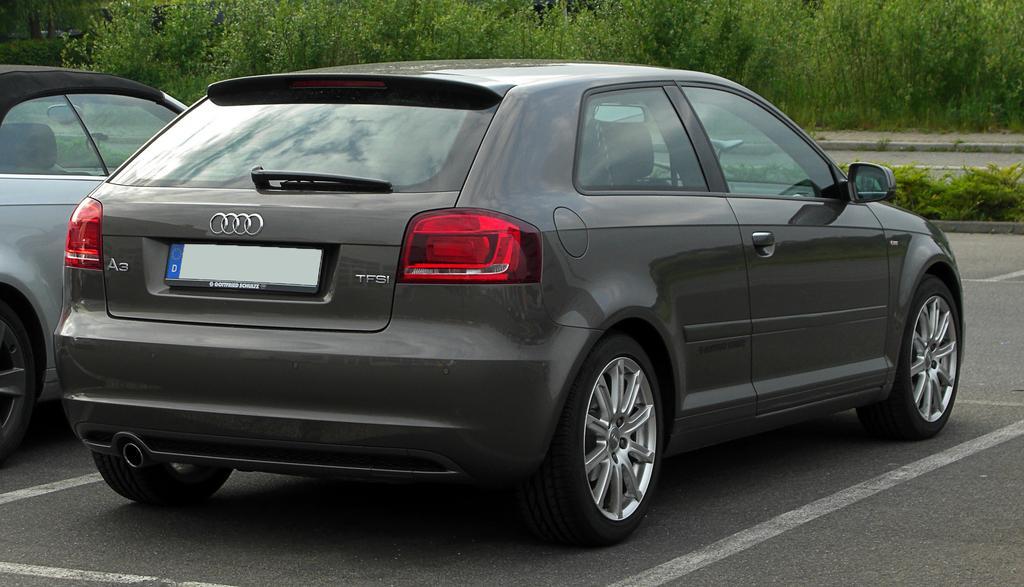Could you give a brief overview of what you see in this image? In this picture I can see vehicles on the road, there are plants, trees. 